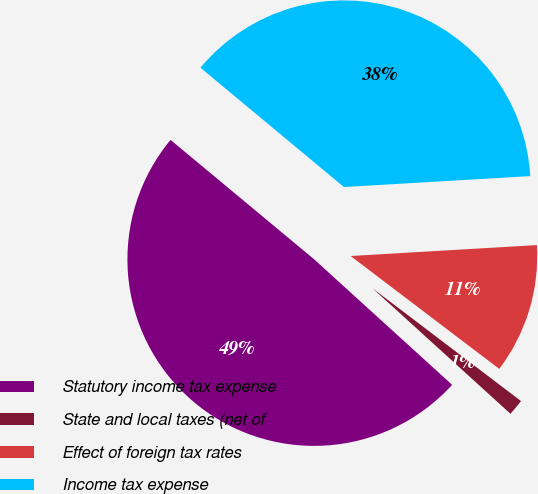Convert chart to OTSL. <chart><loc_0><loc_0><loc_500><loc_500><pie_chart><fcel>Statutory income tax expense<fcel>State and local taxes (net of<fcel>Effect of foreign tax rates<fcel>Income tax expense<nl><fcel>49.3%<fcel>1.41%<fcel>11.27%<fcel>38.03%<nl></chart> 